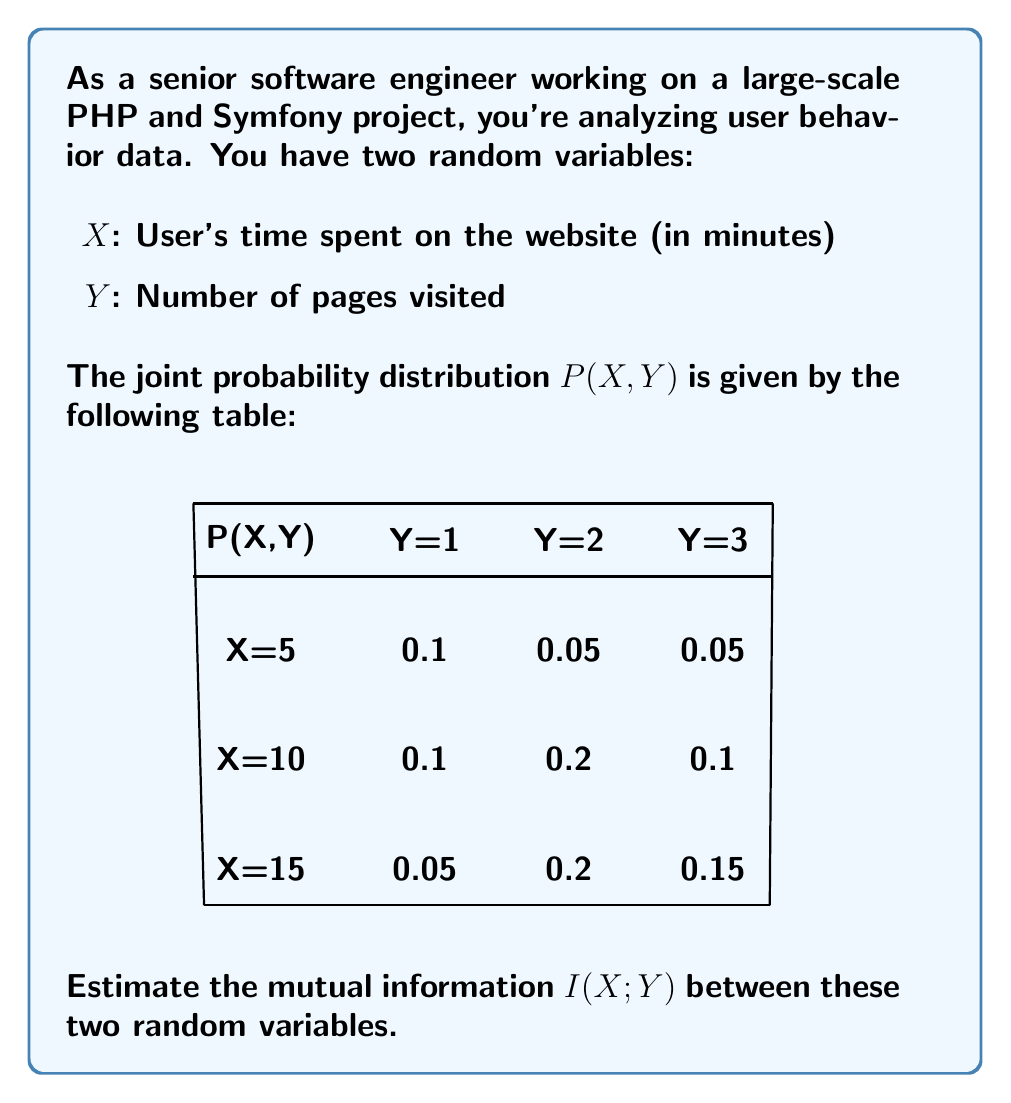What is the answer to this math problem? To calculate the mutual information I(X;Y), we'll follow these steps:

1. Calculate P(X) and P(Y) marginal probabilities
2. Calculate H(X) and H(Y) entropies
3. Calculate H(X,Y) joint entropy
4. Use the formula: I(X;Y) = H(X) + H(Y) - H(X,Y)

Step 1: Marginal probabilities

P(X=5) = 0.1 + 0.05 + 0.05 = 0.2
P(X=10) = 0.1 + 0.2 + 0.1 = 0.4
P(X=15) = 0.05 + 0.2 + 0.15 = 0.4

P(Y=1) = 0.1 + 0.1 + 0.05 = 0.25
P(Y=2) = 0.05 + 0.2 + 0.2 = 0.45
P(Y=3) = 0.05 + 0.1 + 0.15 = 0.3

Step 2: Entropies H(X) and H(Y)

$$H(X) = -\sum_{x} P(X=x) \log_2 P(X=x)$$
$$H(X) = -[0.2 \log_2 0.2 + 0.4 \log_2 0.4 + 0.4 \log_2 0.4] \approx 1.5219$$

$$H(Y) = -\sum_{y} P(Y=y) \log_2 P(Y=y)$$
$$H(Y) = -[0.25 \log_2 0.25 + 0.45 \log_2 0.45 + 0.3 \log_2 0.3] \approx 1.5156$$

Step 3: Joint entropy H(X,Y)

$$H(X,Y) = -\sum_{x,y} P(X=x, Y=y) \log_2 P(X=x, Y=y)$$
$$H(X,Y) = -[0.1 \log_2 0.1 + 0.05 \log_2 0.05 + ... + 0.15 \log_2 0.15] \approx 2.8454$$

Step 4: Mutual Information I(X;Y)

$$I(X;Y) = H(X) + H(Y) - H(X,Y)$$
$$I(X;Y) = 1.5219 + 1.5156 - 2.8454 \approx 0.1921$$

Therefore, the mutual information I(X;Y) is approximately 0.1921 bits.
Answer: $I(X;Y) \approx 0.1921$ bits 